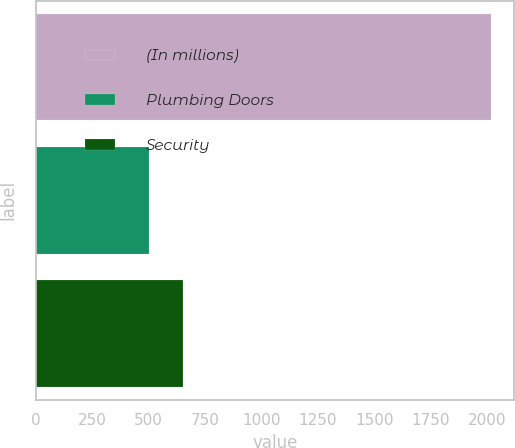Convert chart. <chart><loc_0><loc_0><loc_500><loc_500><bar_chart><fcel>(In millions)<fcel>Plumbing Doors<fcel>Security<nl><fcel>2017<fcel>502.9<fcel>654.31<nl></chart> 